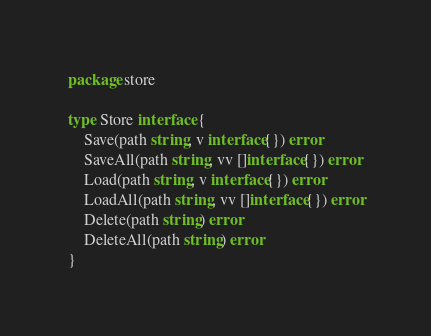<code> <loc_0><loc_0><loc_500><loc_500><_Go_>package store

type Store interface {
	Save(path string, v interface{}) error
	SaveAll(path string, vv []interface{}) error
	Load(path string, v interface{}) error
	LoadAll(path string, vv []interface{}) error
	Delete(path string) error
	DeleteAll(path string) error
}
</code> 